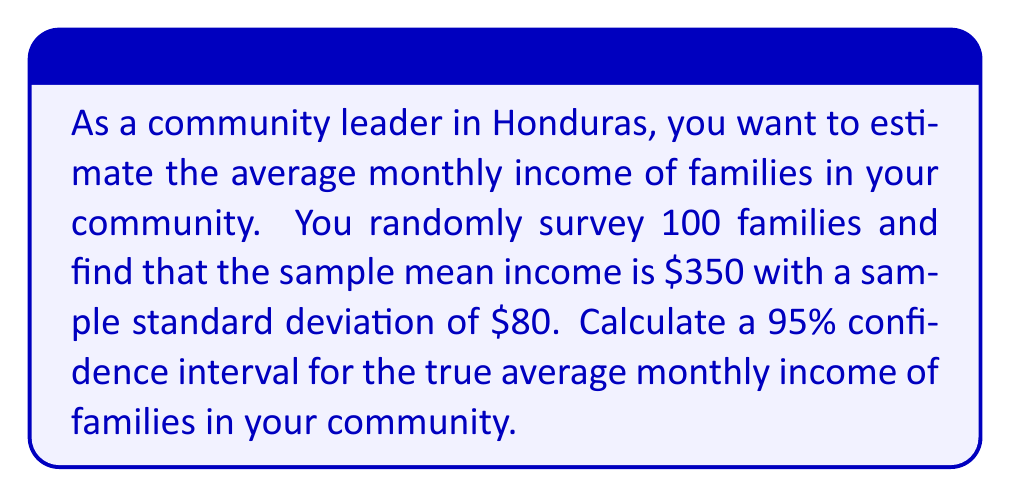Provide a solution to this math problem. Let's approach this step-by-step:

1) We are dealing with a confidence interval for a population mean. The formula for this is:

   $$\bar{x} \pm t_{\alpha/2} \cdot \frac{s}{\sqrt{n}}$$

   Where:
   $\bar{x}$ is the sample mean
   $t_{\alpha/2}$ is the t-value for the desired confidence level
   $s$ is the sample standard deviation
   $n$ is the sample size

2) We know:
   $\bar{x} = $350
   $s = $80
   $n = 100
   Confidence level = 95% (so $\alpha = 0.05$)

3) For a 95% confidence interval with 99 degrees of freedom (n-1), the t-value is approximately 1.984 (you would typically look this up in a t-table).

4) Now let's plug these values into our formula:

   $$350 \pm 1.984 \cdot \frac{80}{\sqrt{100}}$$

5) Simplify:
   $$350 \pm 1.984 \cdot \frac{80}{10} = 350 \pm 1.984 \cdot 8 = 350 \pm 15.872$$

6) Therefore, our confidence interval is:

   $$[$350 - $15.872, $350 + $15.872] = [$334.128, $365.872]$$

7) Rounding to the nearest dollar:

   $$[$334, $366]$$

This means we can be 95% confident that the true average monthly income for families in the community is between $334 and $366.
Answer: [$334, $366] 